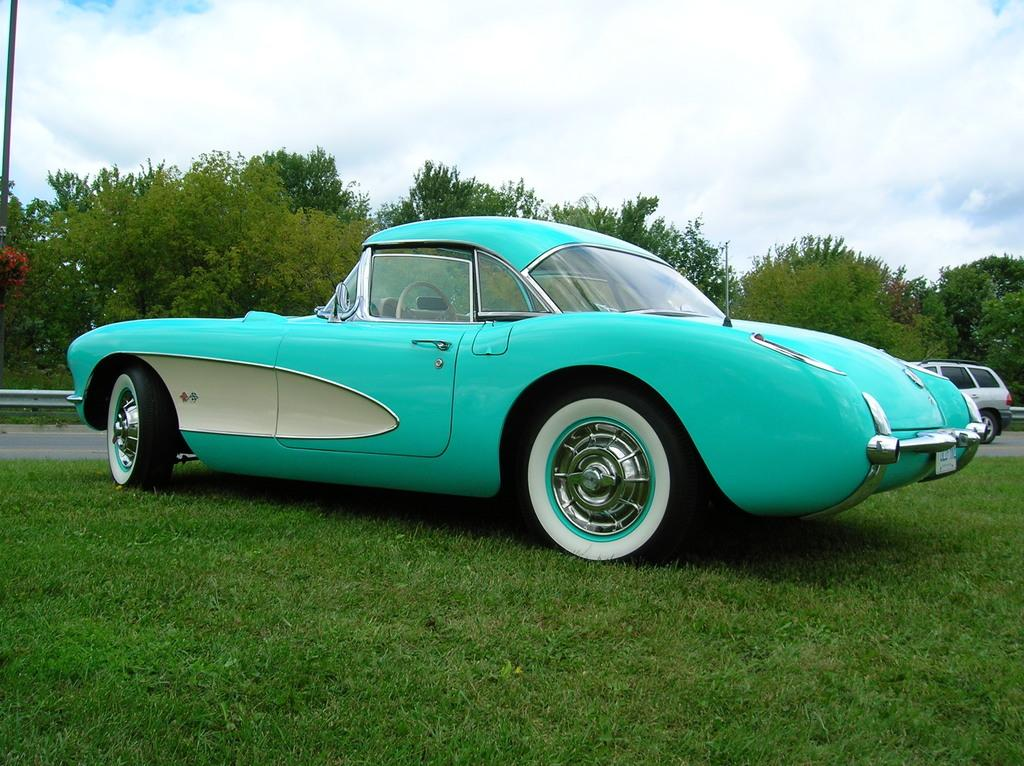What is the main subject of the image? The main subject of the image is a car. What features can be seen on the car? The car has mirrors and a door. Where is the car located in the image? The car is parked on a grass field. What else can be seen in the background of the image? There is another car parked on the road, a metal railing, and a group of trees in the background. How many bees can be seen buzzing around the car in the image? There are no bees present in the image; it only features a car, a grass field, and elements in the background. What type of kitty is sitting on the hood of the car in the image? There is no kitty present on the car or anywhere else in the image. 